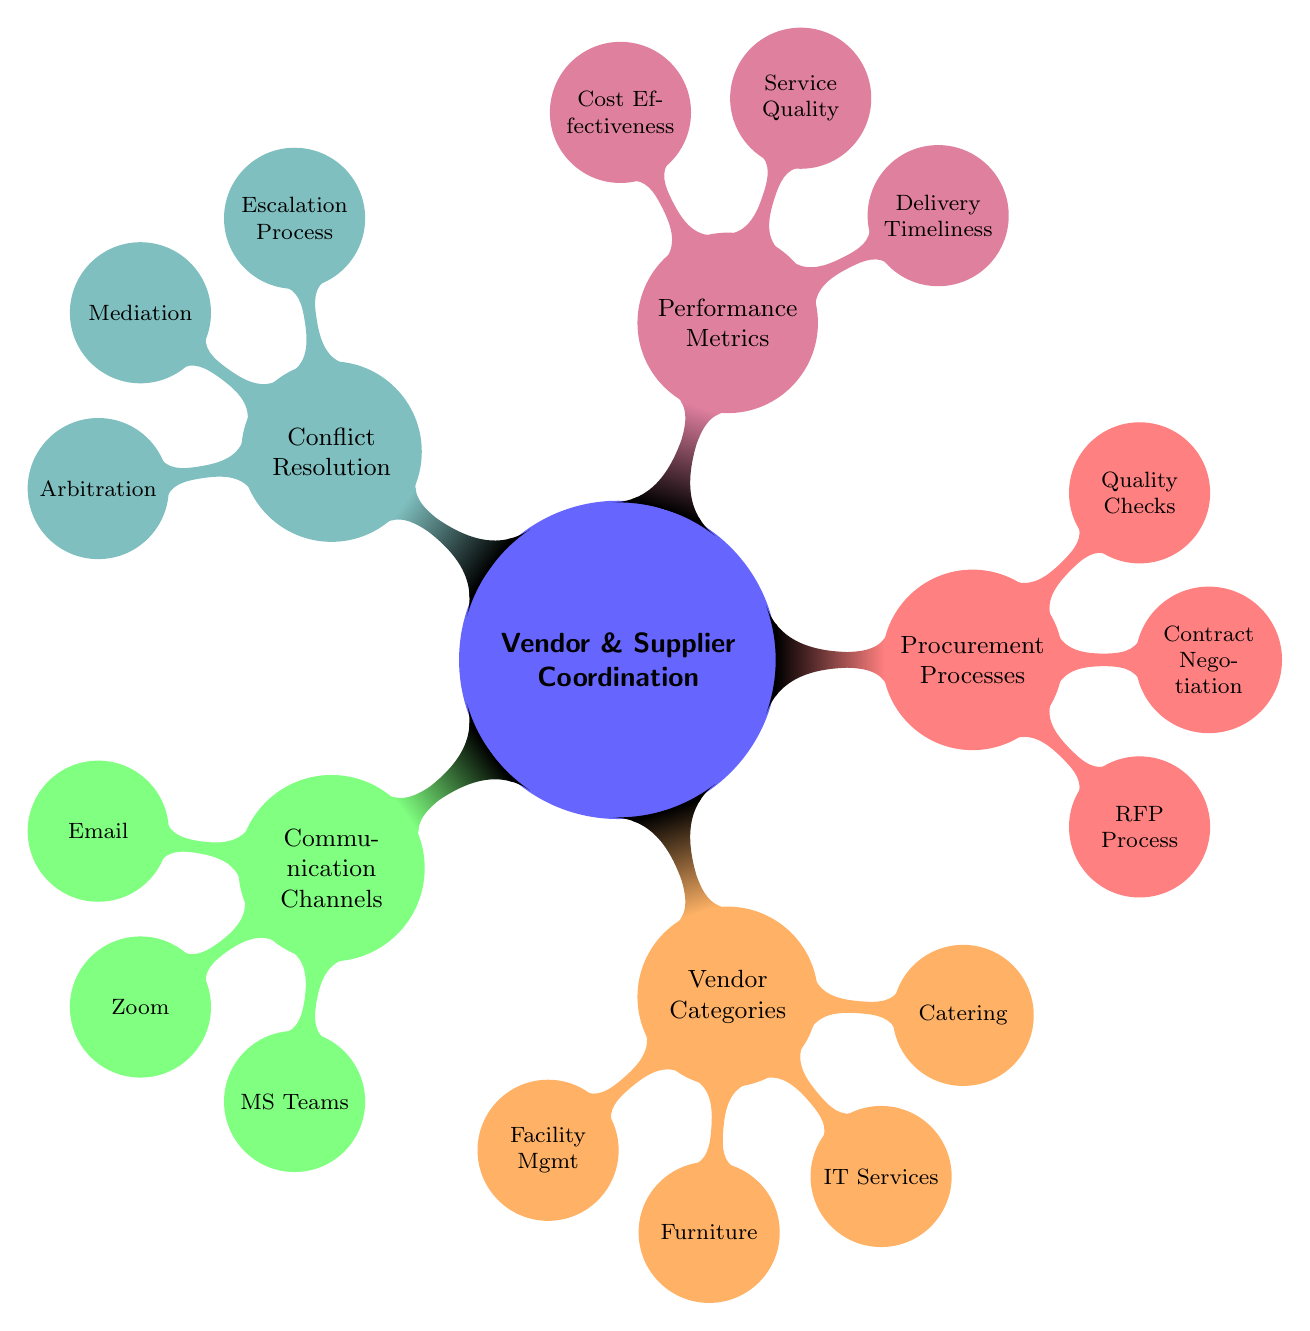What are the three main communication channels listed? The diagram shows three main communication channels under the "Communication Channels" node: Email Communication, Teleconferencing, and Instant Messaging.
Answer: Email, Zoom, MS Teams Who is the vendor for IT Services? Within the "Vendor Categories" section, the vendor listed for IT Services is Dell Technologies.
Answer: Dell Technologies How many vendor categories are identified in the diagram? The diagram includes five major vendor categories: Facility Management, Furniture Suppliers, IT Services, 
Catering Services, indicating a total of five categories.
Answer: 4 What are the performance metrics included? The "Performance Metrics" node shows three specifics: Delivery Timeliness, Service Quality, and Cost Effectiveness, indicating key areas for evaluation.
Answer: Delivery Timeliness, Service Quality, Cost Effectiveness Which conflict resolution method involves a third party? The "Conflict Resolution" section mentions Mediation as the method that entails third-party involvement to help resolve conflicts between the corporation and vendors.
Answer: Mediation What is the process for contract negotiation listed? Under "Procurement Processes," the specific process for Contract Negotiation is labeled as Legal Team Review, highlighting the involvement of the legal department in this stage.
Answer: Legal Team Review How are quality checks ensured according to the diagram? The diagram specifies that quality checks follow ISO 9001 Standards, indicating adherence to internationally recognized quality management principles.
Answer: ISO 9001 Standards What is the escalation process referred to in conflict resolution? In the "Conflict Resolution" section, the Escalation Process is referred to as the Escalation Matrix, indicating a structured method for escalating issues within vendor relationships.
Answer: Escalation Matrix 